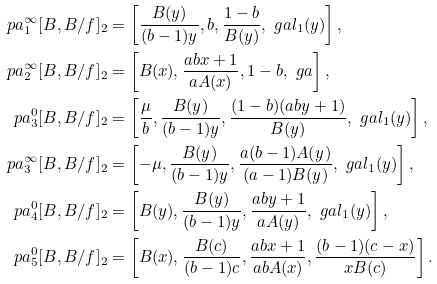Convert formula to latex. <formula><loc_0><loc_0><loc_500><loc_500>\ p a _ { 1 } ^ { \infty } [ B , B / f ] _ { 2 } & = \left [ \frac { B ( y ) } { ( b - 1 ) y } , b , \frac { 1 - b } { B ( y ) } , \ g a l _ { 1 } ( y ) \right ] , \\ \ p a _ { 2 } ^ { \infty } [ B , B / f ] _ { 2 } & = \left [ B ( x ) , \frac { a b x + 1 } { a A ( x ) } , 1 - b , \ g a \right ] , \\ \ p a _ { 3 } ^ { 0 } [ B , B / f ] _ { 2 } & = \left [ \frac { \mu } { b } , \frac { B ( y ) } { ( b - 1 ) y } , \frac { ( 1 - b ) ( a b y + 1 ) } { B ( y ) } , \ g a l _ { 1 } ( y ) \right ] , \\ \ p a _ { 3 } ^ { \infty } [ B , B / f ] _ { 2 } & = \left [ - \mu , \frac { B ( y ) } { ( b - 1 ) y } , \frac { a ( b - 1 ) A ( y ) } { ( a - 1 ) B ( y ) } , \ g a l _ { 1 } ( y ) \right ] , \\ \ p a _ { 4 } ^ { 0 } [ B , B / f ] _ { 2 } & = \left [ B ( y ) , \frac { B ( y ) } { ( b - 1 ) y } , \frac { a b y + 1 } { a A ( y ) } , \ g a l _ { 1 } ( y ) \right ] , \\ \ p a _ { 5 } ^ { 0 } [ B , B / f ] _ { 2 } & = \left [ B ( x ) , \frac { B ( c ) } { ( b - 1 ) c } , \frac { a b x + 1 } { a b A ( x ) } , \frac { ( b - 1 ) ( c - x ) } { x B ( c ) } \right ] .</formula> 